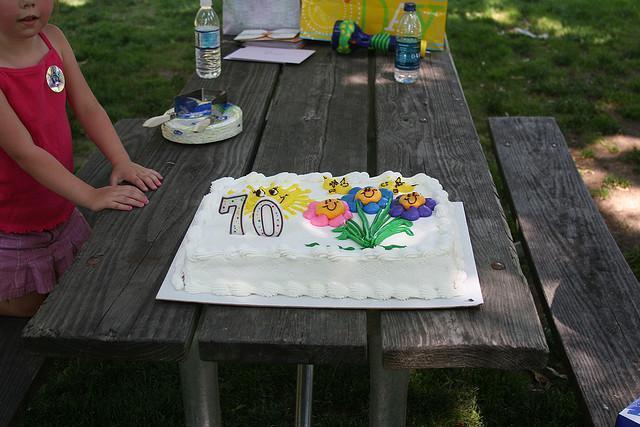What item is drawn on the cake?
From the following four choices, select the correct answer to address the question.
Options: Stalactite, sun, earth, moon. Sun. 